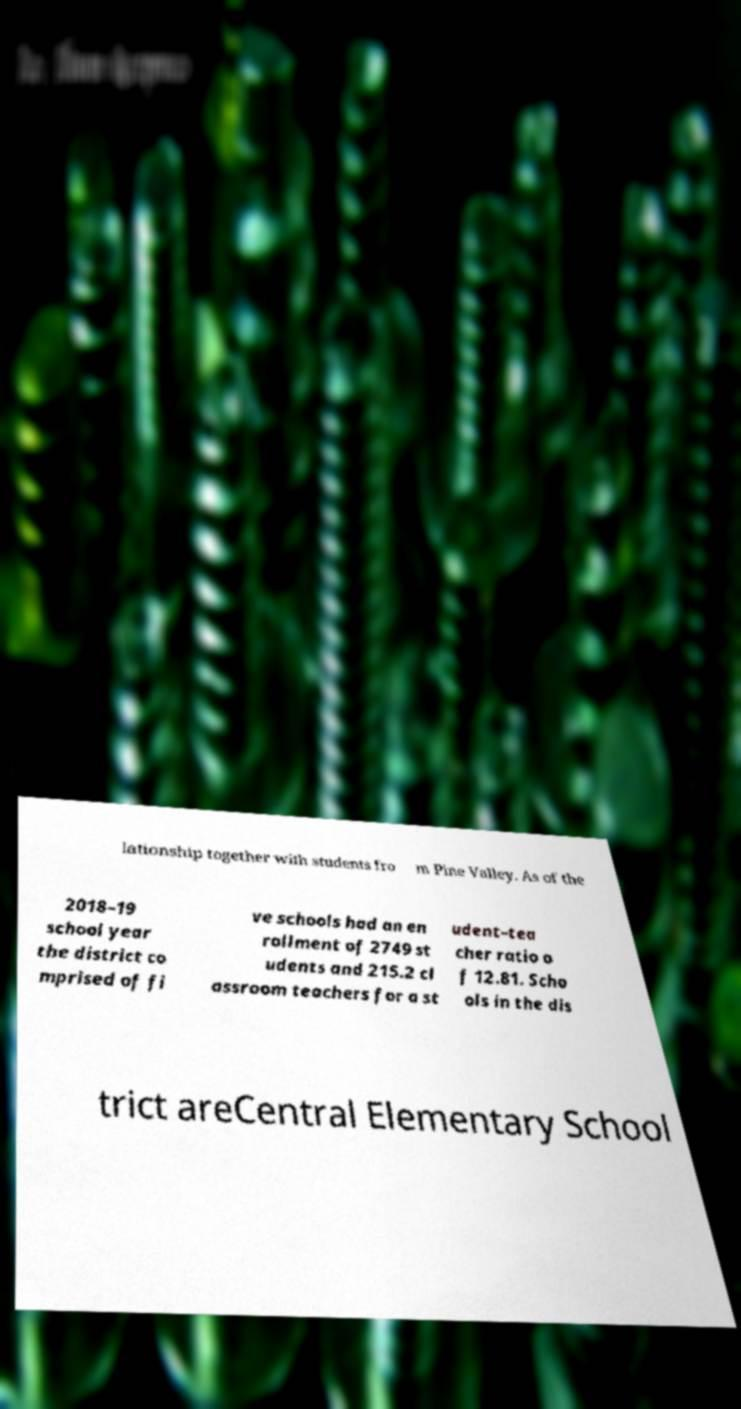I need the written content from this picture converted into text. Can you do that? lationship together with students fro m Pine Valley. As of the 2018–19 school year the district co mprised of fi ve schools had an en rollment of 2749 st udents and 215.2 cl assroom teachers for a st udent–tea cher ratio o f 12.81. Scho ols in the dis trict areCentral Elementary School 